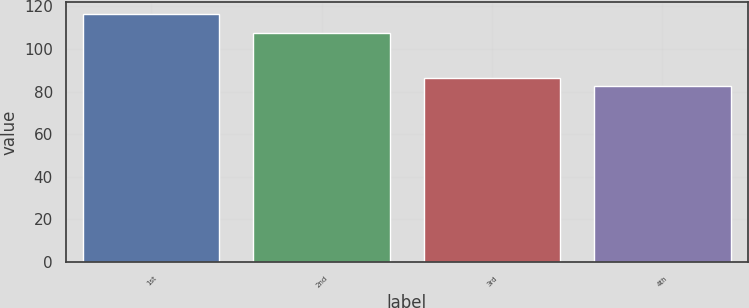<chart> <loc_0><loc_0><loc_500><loc_500><bar_chart><fcel>1st<fcel>2nd<fcel>3rd<fcel>4th<nl><fcel>116.29<fcel>107.37<fcel>86.17<fcel>82.82<nl></chart> 